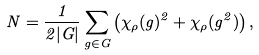Convert formula to latex. <formula><loc_0><loc_0><loc_500><loc_500>N = \frac { 1 } { 2 | G | } \sum _ { g \in G } \left ( \chi _ { \rho } ( g ) ^ { 2 } + \chi _ { \rho } ( g ^ { 2 } ) \right ) ,</formula> 